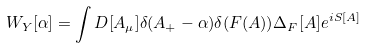Convert formula to latex. <formula><loc_0><loc_0><loc_500><loc_500>W _ { Y } [ \alpha ] = \int D [ A _ { \mu } ] \delta ( A _ { + } - \alpha ) \delta ( F ( A ) ) \Delta _ { F } [ A ] e ^ { i S [ A ] }</formula> 